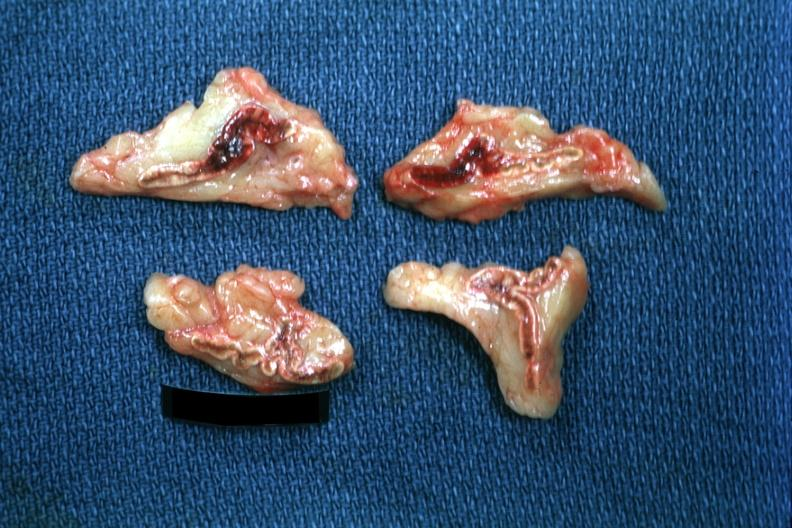s endocrine present?
Answer the question using a single word or phrase. Yes 